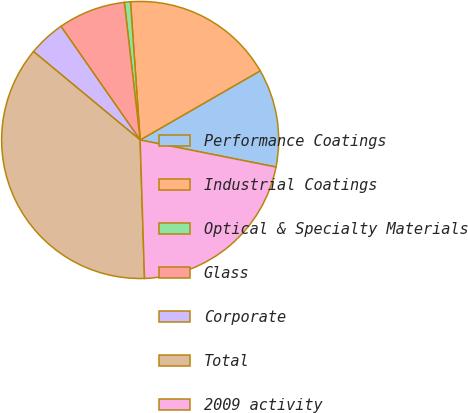<chart> <loc_0><loc_0><loc_500><loc_500><pie_chart><fcel>Performance Coatings<fcel>Industrial Coatings<fcel>Optical & Specialty Materials<fcel>Glass<fcel>Corporate<fcel>Total<fcel>2009 activity<nl><fcel>11.45%<fcel>17.79%<fcel>0.71%<fcel>7.87%<fcel>4.29%<fcel>36.52%<fcel>21.37%<nl></chart> 